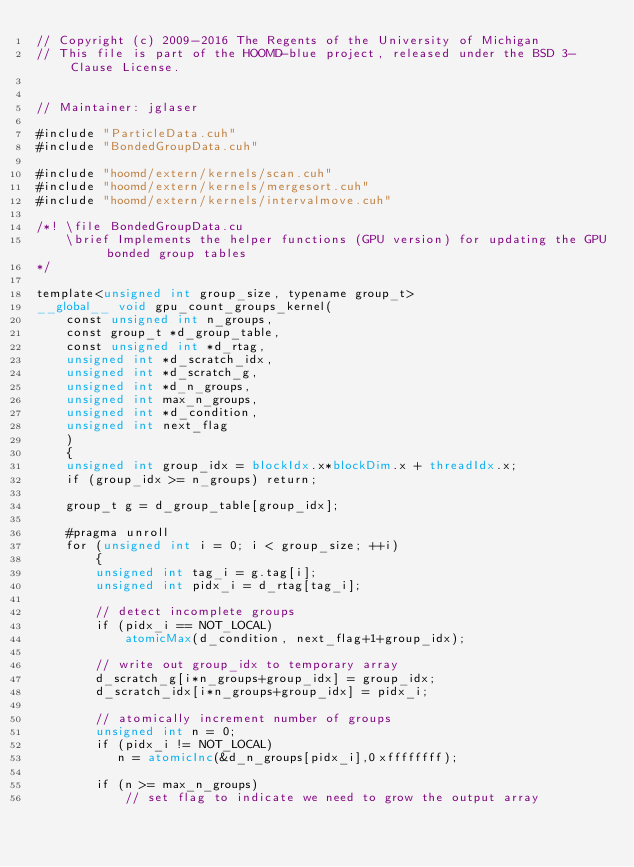<code> <loc_0><loc_0><loc_500><loc_500><_Cuda_>// Copyright (c) 2009-2016 The Regents of the University of Michigan
// This file is part of the HOOMD-blue project, released under the BSD 3-Clause License.


// Maintainer: jglaser

#include "ParticleData.cuh"
#include "BondedGroupData.cuh"

#include "hoomd/extern/kernels/scan.cuh"
#include "hoomd/extern/kernels/mergesort.cuh"
#include "hoomd/extern/kernels/intervalmove.cuh"

/*! \file BondedGroupData.cu
    \brief Implements the helper functions (GPU version) for updating the GPU bonded group tables
*/

template<unsigned int group_size, typename group_t>
__global__ void gpu_count_groups_kernel(
    const unsigned int n_groups,
    const group_t *d_group_table,
    const unsigned int *d_rtag,
    unsigned int *d_scratch_idx,
    unsigned int *d_scratch_g,
    unsigned int *d_n_groups,
    unsigned int max_n_groups,
    unsigned int *d_condition,
    unsigned int next_flag
    )
    {
    unsigned int group_idx = blockIdx.x*blockDim.x + threadIdx.x;
    if (group_idx >= n_groups) return;

    group_t g = d_group_table[group_idx];

    #pragma unroll
    for (unsigned int i = 0; i < group_size; ++i)
        {
        unsigned int tag_i = g.tag[i];
        unsigned int pidx_i = d_rtag[tag_i];

        // detect incomplete groups
        if (pidx_i == NOT_LOCAL)
            atomicMax(d_condition, next_flag+1+group_idx);

        // write out group_idx to temporary array
        d_scratch_g[i*n_groups+group_idx] = group_idx;
        d_scratch_idx[i*n_groups+group_idx] = pidx_i;

        // atomically increment number of groups
        unsigned int n = 0;
        if (pidx_i != NOT_LOCAL)
           n = atomicInc(&d_n_groups[pidx_i],0xffffffff);

        if (n >= max_n_groups)
            // set flag to indicate we need to grow the output array</code> 